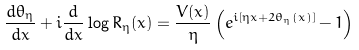<formula> <loc_0><loc_0><loc_500><loc_500>\frac { d \theta _ { \eta } } { d x } + i \frac { d } { d x } \log R _ { \eta } ( x ) = \frac { V ( x ) } \eta \left ( e ^ { i [ \eta x + 2 \theta _ { \eta } ( x ) ] } - 1 \right )</formula> 